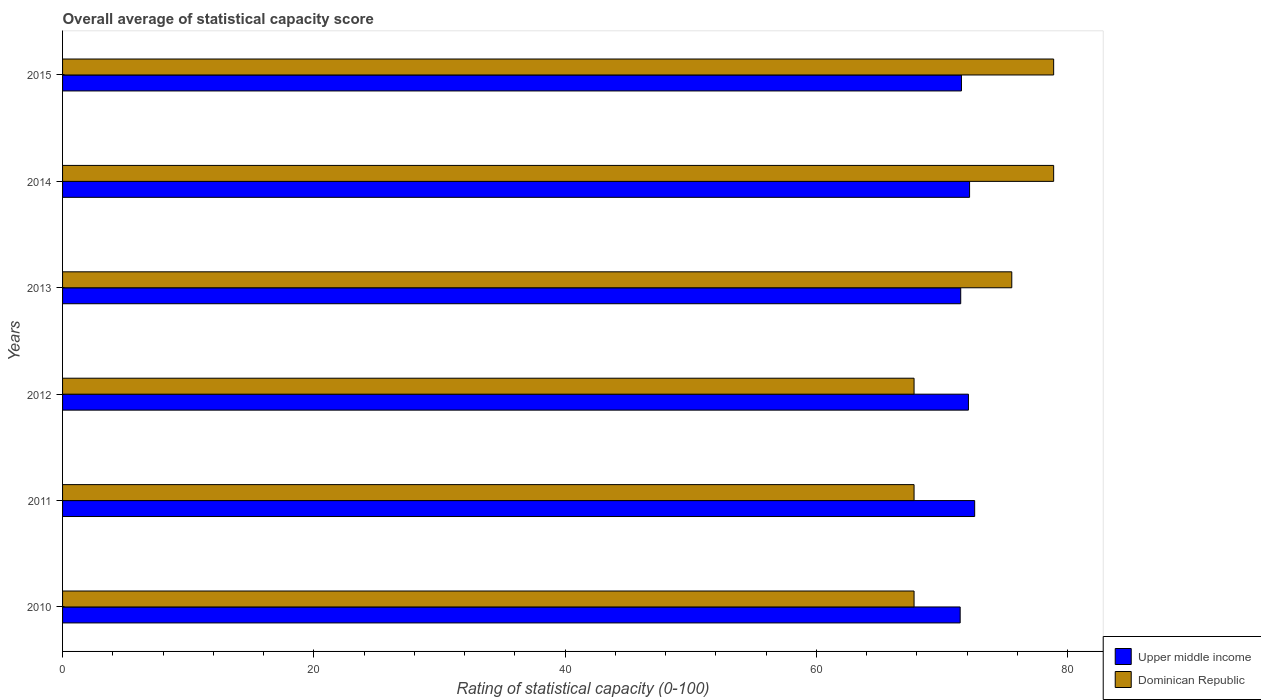How many groups of bars are there?
Ensure brevity in your answer.  6. Are the number of bars per tick equal to the number of legend labels?
Provide a succinct answer. Yes. Are the number of bars on each tick of the Y-axis equal?
Make the answer very short. Yes. How many bars are there on the 4th tick from the top?
Give a very brief answer. 2. How many bars are there on the 1st tick from the bottom?
Provide a succinct answer. 2. What is the rating of statistical capacity in Dominican Republic in 2014?
Give a very brief answer. 78.89. Across all years, what is the maximum rating of statistical capacity in Upper middle income?
Your answer should be very brief. 72.6. Across all years, what is the minimum rating of statistical capacity in Dominican Republic?
Give a very brief answer. 67.78. In which year was the rating of statistical capacity in Dominican Republic maximum?
Keep it short and to the point. 2015. What is the total rating of statistical capacity in Upper middle income in the graph?
Offer a very short reply. 431.39. What is the difference between the rating of statistical capacity in Upper middle income in 2013 and that in 2015?
Give a very brief answer. -0.06. What is the difference between the rating of statistical capacity in Dominican Republic in 2010 and the rating of statistical capacity in Upper middle income in 2013?
Provide a succinct answer. -3.71. What is the average rating of statistical capacity in Upper middle income per year?
Your response must be concise. 71.9. In the year 2014, what is the difference between the rating of statistical capacity in Upper middle income and rating of statistical capacity in Dominican Republic?
Make the answer very short. -6.69. In how many years, is the rating of statistical capacity in Upper middle income greater than 52 ?
Make the answer very short. 6. What is the ratio of the rating of statistical capacity in Dominican Republic in 2010 to that in 2013?
Ensure brevity in your answer.  0.9. Is the rating of statistical capacity in Dominican Republic in 2010 less than that in 2015?
Your answer should be very brief. Yes. Is the difference between the rating of statistical capacity in Upper middle income in 2011 and 2015 greater than the difference between the rating of statistical capacity in Dominican Republic in 2011 and 2015?
Offer a very short reply. Yes. What is the difference between the highest and the second highest rating of statistical capacity in Dominican Republic?
Keep it short and to the point. 1.111111110674301e-5. What is the difference between the highest and the lowest rating of statistical capacity in Upper middle income?
Ensure brevity in your answer.  1.16. In how many years, is the rating of statistical capacity in Upper middle income greater than the average rating of statistical capacity in Upper middle income taken over all years?
Give a very brief answer. 3. What does the 1st bar from the top in 2013 represents?
Your answer should be very brief. Dominican Republic. What does the 2nd bar from the bottom in 2012 represents?
Make the answer very short. Dominican Republic. Are the values on the major ticks of X-axis written in scientific E-notation?
Offer a terse response. No. Does the graph contain grids?
Your response must be concise. No. How many legend labels are there?
Offer a very short reply. 2. How are the legend labels stacked?
Provide a succinct answer. Vertical. What is the title of the graph?
Keep it short and to the point. Overall average of statistical capacity score. Does "United Arab Emirates" appear as one of the legend labels in the graph?
Your answer should be very brief. No. What is the label or title of the X-axis?
Keep it short and to the point. Rating of statistical capacity (0-100). What is the label or title of the Y-axis?
Offer a terse response. Years. What is the Rating of statistical capacity (0-100) in Upper middle income in 2010?
Make the answer very short. 71.45. What is the Rating of statistical capacity (0-100) of Dominican Republic in 2010?
Provide a succinct answer. 67.78. What is the Rating of statistical capacity (0-100) of Upper middle income in 2011?
Give a very brief answer. 72.6. What is the Rating of statistical capacity (0-100) of Dominican Republic in 2011?
Provide a short and direct response. 67.78. What is the Rating of statistical capacity (0-100) of Upper middle income in 2012?
Provide a succinct answer. 72.11. What is the Rating of statistical capacity (0-100) of Dominican Republic in 2012?
Offer a terse response. 67.78. What is the Rating of statistical capacity (0-100) of Upper middle income in 2013?
Give a very brief answer. 71.49. What is the Rating of statistical capacity (0-100) of Dominican Republic in 2013?
Keep it short and to the point. 75.56. What is the Rating of statistical capacity (0-100) of Upper middle income in 2014?
Make the answer very short. 72.2. What is the Rating of statistical capacity (0-100) of Dominican Republic in 2014?
Your answer should be compact. 78.89. What is the Rating of statistical capacity (0-100) in Upper middle income in 2015?
Provide a short and direct response. 71.55. What is the Rating of statistical capacity (0-100) in Dominican Republic in 2015?
Your answer should be compact. 78.89. Across all years, what is the maximum Rating of statistical capacity (0-100) of Upper middle income?
Make the answer very short. 72.6. Across all years, what is the maximum Rating of statistical capacity (0-100) of Dominican Republic?
Offer a very short reply. 78.89. Across all years, what is the minimum Rating of statistical capacity (0-100) in Upper middle income?
Provide a succinct answer. 71.45. Across all years, what is the minimum Rating of statistical capacity (0-100) in Dominican Republic?
Your answer should be very brief. 67.78. What is the total Rating of statistical capacity (0-100) in Upper middle income in the graph?
Offer a terse response. 431.39. What is the total Rating of statistical capacity (0-100) of Dominican Republic in the graph?
Give a very brief answer. 436.67. What is the difference between the Rating of statistical capacity (0-100) in Upper middle income in 2010 and that in 2011?
Provide a short and direct response. -1.16. What is the difference between the Rating of statistical capacity (0-100) in Dominican Republic in 2010 and that in 2011?
Your response must be concise. 0. What is the difference between the Rating of statistical capacity (0-100) of Upper middle income in 2010 and that in 2012?
Provide a short and direct response. -0.66. What is the difference between the Rating of statistical capacity (0-100) of Upper middle income in 2010 and that in 2013?
Keep it short and to the point. -0.04. What is the difference between the Rating of statistical capacity (0-100) in Dominican Republic in 2010 and that in 2013?
Your answer should be compact. -7.78. What is the difference between the Rating of statistical capacity (0-100) in Upper middle income in 2010 and that in 2014?
Ensure brevity in your answer.  -0.75. What is the difference between the Rating of statistical capacity (0-100) in Dominican Republic in 2010 and that in 2014?
Ensure brevity in your answer.  -11.11. What is the difference between the Rating of statistical capacity (0-100) of Upper middle income in 2010 and that in 2015?
Provide a succinct answer. -0.1. What is the difference between the Rating of statistical capacity (0-100) of Dominican Republic in 2010 and that in 2015?
Provide a succinct answer. -11.11. What is the difference between the Rating of statistical capacity (0-100) of Upper middle income in 2011 and that in 2012?
Your answer should be very brief. 0.5. What is the difference between the Rating of statistical capacity (0-100) in Dominican Republic in 2011 and that in 2012?
Offer a very short reply. 0. What is the difference between the Rating of statistical capacity (0-100) of Dominican Republic in 2011 and that in 2013?
Your response must be concise. -7.78. What is the difference between the Rating of statistical capacity (0-100) in Upper middle income in 2011 and that in 2014?
Your answer should be very brief. 0.41. What is the difference between the Rating of statistical capacity (0-100) in Dominican Republic in 2011 and that in 2014?
Your answer should be very brief. -11.11. What is the difference between the Rating of statistical capacity (0-100) in Upper middle income in 2011 and that in 2015?
Make the answer very short. 1.05. What is the difference between the Rating of statistical capacity (0-100) of Dominican Republic in 2011 and that in 2015?
Ensure brevity in your answer.  -11.11. What is the difference between the Rating of statistical capacity (0-100) of Upper middle income in 2012 and that in 2013?
Your response must be concise. 0.61. What is the difference between the Rating of statistical capacity (0-100) in Dominican Republic in 2012 and that in 2013?
Make the answer very short. -7.78. What is the difference between the Rating of statistical capacity (0-100) in Upper middle income in 2012 and that in 2014?
Provide a short and direct response. -0.09. What is the difference between the Rating of statistical capacity (0-100) in Dominican Republic in 2012 and that in 2014?
Your answer should be compact. -11.11. What is the difference between the Rating of statistical capacity (0-100) of Upper middle income in 2012 and that in 2015?
Your answer should be compact. 0.56. What is the difference between the Rating of statistical capacity (0-100) of Dominican Republic in 2012 and that in 2015?
Your answer should be very brief. -11.11. What is the difference between the Rating of statistical capacity (0-100) of Upper middle income in 2013 and that in 2014?
Ensure brevity in your answer.  -0.7. What is the difference between the Rating of statistical capacity (0-100) in Upper middle income in 2013 and that in 2015?
Offer a terse response. -0.06. What is the difference between the Rating of statistical capacity (0-100) in Upper middle income in 2014 and that in 2015?
Your response must be concise. 0.65. What is the difference between the Rating of statistical capacity (0-100) in Upper middle income in 2010 and the Rating of statistical capacity (0-100) in Dominican Republic in 2011?
Make the answer very short. 3.67. What is the difference between the Rating of statistical capacity (0-100) in Upper middle income in 2010 and the Rating of statistical capacity (0-100) in Dominican Republic in 2012?
Offer a terse response. 3.67. What is the difference between the Rating of statistical capacity (0-100) of Upper middle income in 2010 and the Rating of statistical capacity (0-100) of Dominican Republic in 2013?
Offer a very short reply. -4.11. What is the difference between the Rating of statistical capacity (0-100) in Upper middle income in 2010 and the Rating of statistical capacity (0-100) in Dominican Republic in 2014?
Your answer should be compact. -7.44. What is the difference between the Rating of statistical capacity (0-100) of Upper middle income in 2010 and the Rating of statistical capacity (0-100) of Dominican Republic in 2015?
Ensure brevity in your answer.  -7.44. What is the difference between the Rating of statistical capacity (0-100) in Upper middle income in 2011 and the Rating of statistical capacity (0-100) in Dominican Republic in 2012?
Your answer should be compact. 4.82. What is the difference between the Rating of statistical capacity (0-100) in Upper middle income in 2011 and the Rating of statistical capacity (0-100) in Dominican Republic in 2013?
Your response must be concise. -2.95. What is the difference between the Rating of statistical capacity (0-100) in Upper middle income in 2011 and the Rating of statistical capacity (0-100) in Dominican Republic in 2014?
Keep it short and to the point. -6.29. What is the difference between the Rating of statistical capacity (0-100) of Upper middle income in 2011 and the Rating of statistical capacity (0-100) of Dominican Republic in 2015?
Your response must be concise. -6.29. What is the difference between the Rating of statistical capacity (0-100) in Upper middle income in 2012 and the Rating of statistical capacity (0-100) in Dominican Republic in 2013?
Your response must be concise. -3.45. What is the difference between the Rating of statistical capacity (0-100) in Upper middle income in 2012 and the Rating of statistical capacity (0-100) in Dominican Republic in 2014?
Offer a very short reply. -6.78. What is the difference between the Rating of statistical capacity (0-100) in Upper middle income in 2012 and the Rating of statistical capacity (0-100) in Dominican Republic in 2015?
Ensure brevity in your answer.  -6.78. What is the difference between the Rating of statistical capacity (0-100) in Upper middle income in 2013 and the Rating of statistical capacity (0-100) in Dominican Republic in 2014?
Offer a terse response. -7.4. What is the difference between the Rating of statistical capacity (0-100) of Upper middle income in 2013 and the Rating of statistical capacity (0-100) of Dominican Republic in 2015?
Offer a terse response. -7.4. What is the difference between the Rating of statistical capacity (0-100) of Upper middle income in 2014 and the Rating of statistical capacity (0-100) of Dominican Republic in 2015?
Give a very brief answer. -6.69. What is the average Rating of statistical capacity (0-100) in Upper middle income per year?
Offer a terse response. 71.9. What is the average Rating of statistical capacity (0-100) in Dominican Republic per year?
Offer a very short reply. 72.78. In the year 2010, what is the difference between the Rating of statistical capacity (0-100) in Upper middle income and Rating of statistical capacity (0-100) in Dominican Republic?
Provide a succinct answer. 3.67. In the year 2011, what is the difference between the Rating of statistical capacity (0-100) of Upper middle income and Rating of statistical capacity (0-100) of Dominican Republic?
Give a very brief answer. 4.82. In the year 2012, what is the difference between the Rating of statistical capacity (0-100) in Upper middle income and Rating of statistical capacity (0-100) in Dominican Republic?
Your answer should be very brief. 4.33. In the year 2013, what is the difference between the Rating of statistical capacity (0-100) in Upper middle income and Rating of statistical capacity (0-100) in Dominican Republic?
Make the answer very short. -4.06. In the year 2014, what is the difference between the Rating of statistical capacity (0-100) in Upper middle income and Rating of statistical capacity (0-100) in Dominican Republic?
Ensure brevity in your answer.  -6.69. In the year 2015, what is the difference between the Rating of statistical capacity (0-100) in Upper middle income and Rating of statistical capacity (0-100) in Dominican Republic?
Your response must be concise. -7.34. What is the ratio of the Rating of statistical capacity (0-100) of Upper middle income in 2010 to that in 2011?
Your answer should be compact. 0.98. What is the ratio of the Rating of statistical capacity (0-100) in Upper middle income in 2010 to that in 2012?
Your response must be concise. 0.99. What is the ratio of the Rating of statistical capacity (0-100) in Dominican Republic in 2010 to that in 2012?
Provide a succinct answer. 1. What is the ratio of the Rating of statistical capacity (0-100) in Upper middle income in 2010 to that in 2013?
Keep it short and to the point. 1. What is the ratio of the Rating of statistical capacity (0-100) of Dominican Republic in 2010 to that in 2013?
Provide a succinct answer. 0.9. What is the ratio of the Rating of statistical capacity (0-100) in Upper middle income in 2010 to that in 2014?
Your answer should be compact. 0.99. What is the ratio of the Rating of statistical capacity (0-100) in Dominican Republic in 2010 to that in 2014?
Your answer should be compact. 0.86. What is the ratio of the Rating of statistical capacity (0-100) of Upper middle income in 2010 to that in 2015?
Offer a terse response. 1. What is the ratio of the Rating of statistical capacity (0-100) of Dominican Republic in 2010 to that in 2015?
Your answer should be very brief. 0.86. What is the ratio of the Rating of statistical capacity (0-100) of Dominican Republic in 2011 to that in 2012?
Offer a terse response. 1. What is the ratio of the Rating of statistical capacity (0-100) of Upper middle income in 2011 to that in 2013?
Your response must be concise. 1.02. What is the ratio of the Rating of statistical capacity (0-100) in Dominican Republic in 2011 to that in 2013?
Ensure brevity in your answer.  0.9. What is the ratio of the Rating of statistical capacity (0-100) in Upper middle income in 2011 to that in 2014?
Offer a terse response. 1.01. What is the ratio of the Rating of statistical capacity (0-100) of Dominican Republic in 2011 to that in 2014?
Your answer should be compact. 0.86. What is the ratio of the Rating of statistical capacity (0-100) of Upper middle income in 2011 to that in 2015?
Your answer should be compact. 1.01. What is the ratio of the Rating of statistical capacity (0-100) in Dominican Republic in 2011 to that in 2015?
Provide a short and direct response. 0.86. What is the ratio of the Rating of statistical capacity (0-100) in Upper middle income in 2012 to that in 2013?
Your answer should be very brief. 1.01. What is the ratio of the Rating of statistical capacity (0-100) of Dominican Republic in 2012 to that in 2013?
Ensure brevity in your answer.  0.9. What is the ratio of the Rating of statistical capacity (0-100) of Upper middle income in 2012 to that in 2014?
Offer a very short reply. 1. What is the ratio of the Rating of statistical capacity (0-100) of Dominican Republic in 2012 to that in 2014?
Provide a short and direct response. 0.86. What is the ratio of the Rating of statistical capacity (0-100) of Dominican Republic in 2012 to that in 2015?
Your answer should be compact. 0.86. What is the ratio of the Rating of statistical capacity (0-100) of Upper middle income in 2013 to that in 2014?
Offer a very short reply. 0.99. What is the ratio of the Rating of statistical capacity (0-100) of Dominican Republic in 2013 to that in 2014?
Provide a short and direct response. 0.96. What is the ratio of the Rating of statistical capacity (0-100) in Dominican Republic in 2013 to that in 2015?
Offer a terse response. 0.96. What is the ratio of the Rating of statistical capacity (0-100) of Upper middle income in 2014 to that in 2015?
Offer a very short reply. 1.01. What is the difference between the highest and the second highest Rating of statistical capacity (0-100) in Upper middle income?
Provide a short and direct response. 0.41. What is the difference between the highest and the second highest Rating of statistical capacity (0-100) of Dominican Republic?
Your answer should be compact. 0. What is the difference between the highest and the lowest Rating of statistical capacity (0-100) of Upper middle income?
Provide a succinct answer. 1.16. What is the difference between the highest and the lowest Rating of statistical capacity (0-100) of Dominican Republic?
Your response must be concise. 11.11. 